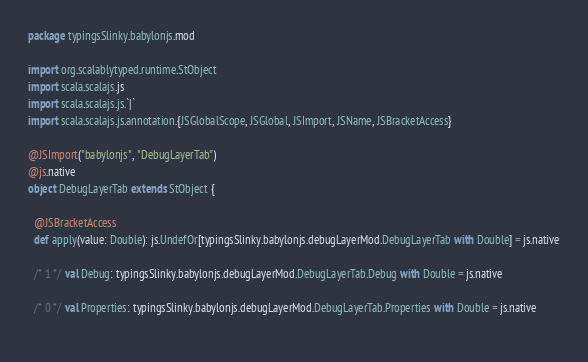<code> <loc_0><loc_0><loc_500><loc_500><_Scala_>package typingsSlinky.babylonjs.mod

import org.scalablytyped.runtime.StObject
import scala.scalajs.js
import scala.scalajs.js.`|`
import scala.scalajs.js.annotation.{JSGlobalScope, JSGlobal, JSImport, JSName, JSBracketAccess}

@JSImport("babylonjs", "DebugLayerTab")
@js.native
object DebugLayerTab extends StObject {
  
  @JSBracketAccess
  def apply(value: Double): js.UndefOr[typingsSlinky.babylonjs.debugLayerMod.DebugLayerTab with Double] = js.native
  
  /* 1 */ val Debug: typingsSlinky.babylonjs.debugLayerMod.DebugLayerTab.Debug with Double = js.native
  
  /* 0 */ val Properties: typingsSlinky.babylonjs.debugLayerMod.DebugLayerTab.Properties with Double = js.native
  </code> 